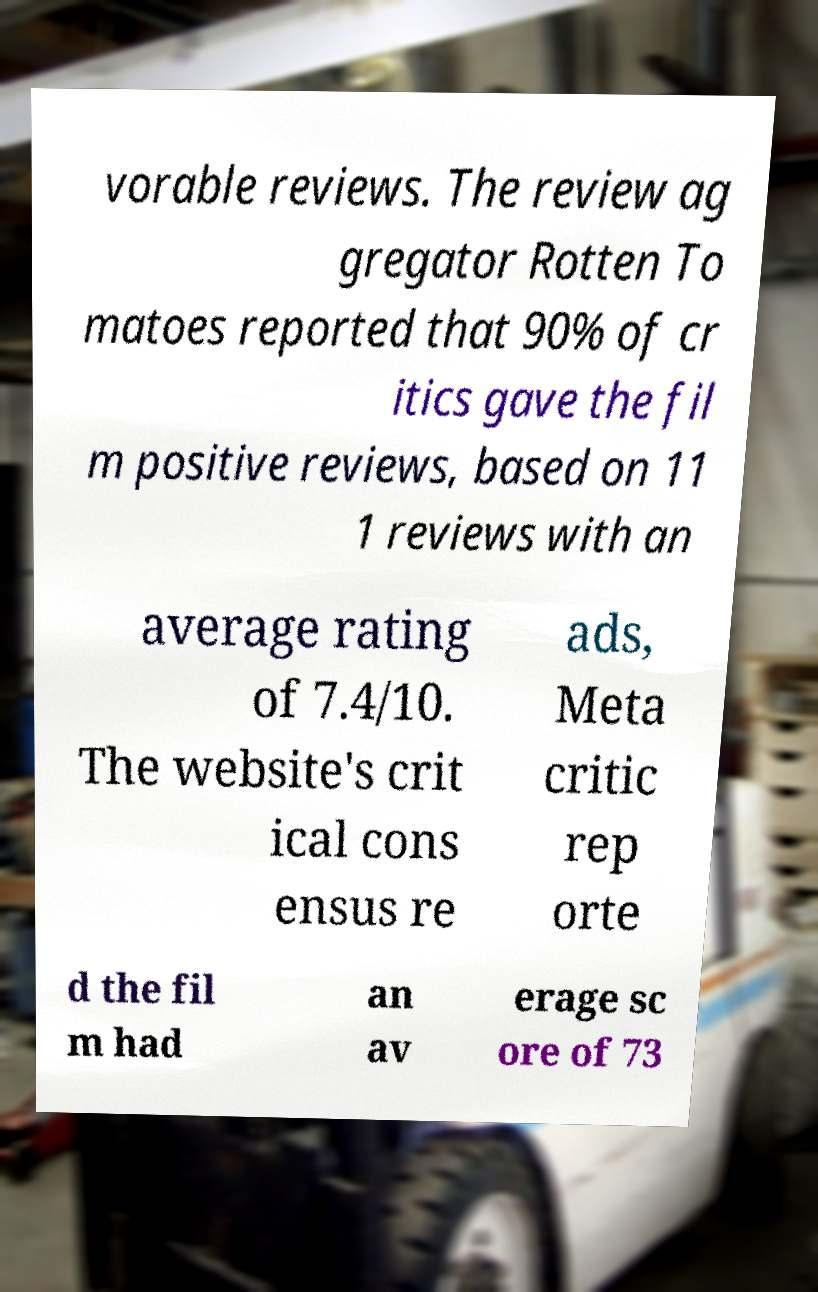Could you extract and type out the text from this image? vorable reviews. The review ag gregator Rotten To matoes reported that 90% of cr itics gave the fil m positive reviews, based on 11 1 reviews with an average rating of 7.4/10. The website's crit ical cons ensus re ads, Meta critic rep orte d the fil m had an av erage sc ore of 73 